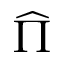Convert formula to latex. <formula><loc_0><loc_0><loc_500><loc_500>\widehat { \Pi }</formula> 